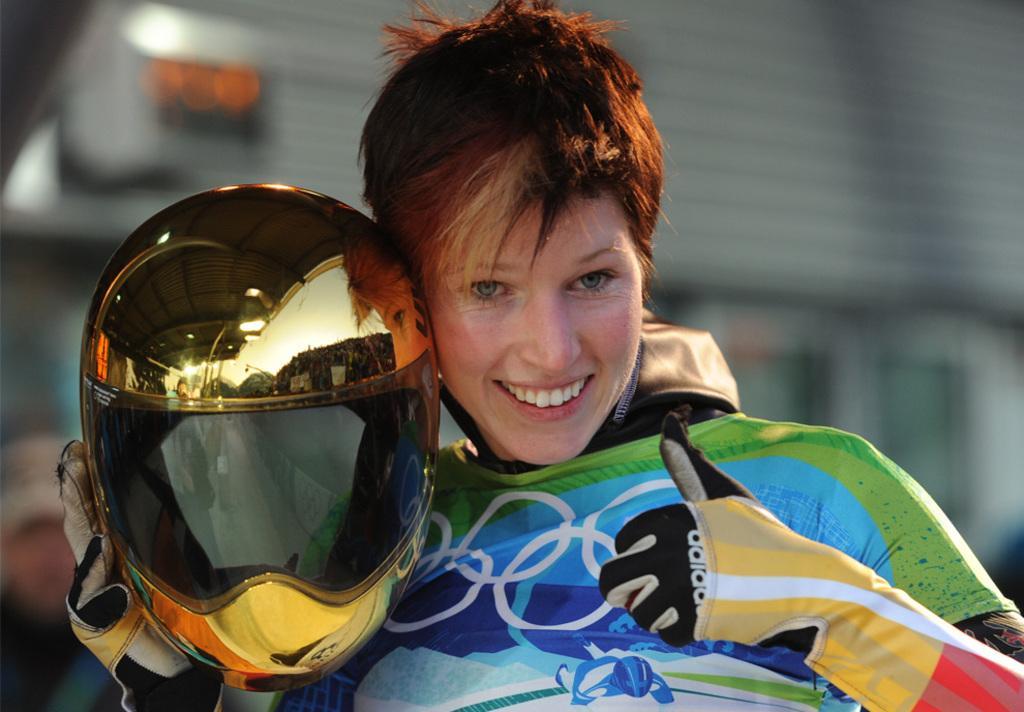In one or two sentences, can you explain what this image depicts? In this image there is a person wearing gloves and he is holding a helmet in his hand. Background is blurry. 